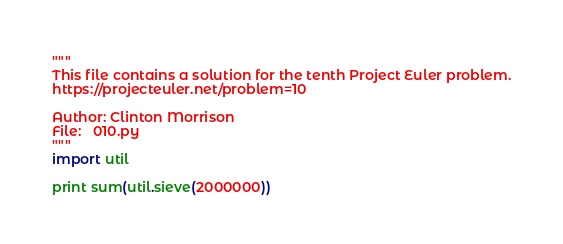Convert code to text. <code><loc_0><loc_0><loc_500><loc_500><_Python_>"""
This file contains a solution for the tenth Project Euler problem.
https://projecteuler.net/problem=10

Author: Clinton Morrison
File:   010.py
"""
import util

print sum(util.sieve(2000000))
</code> 